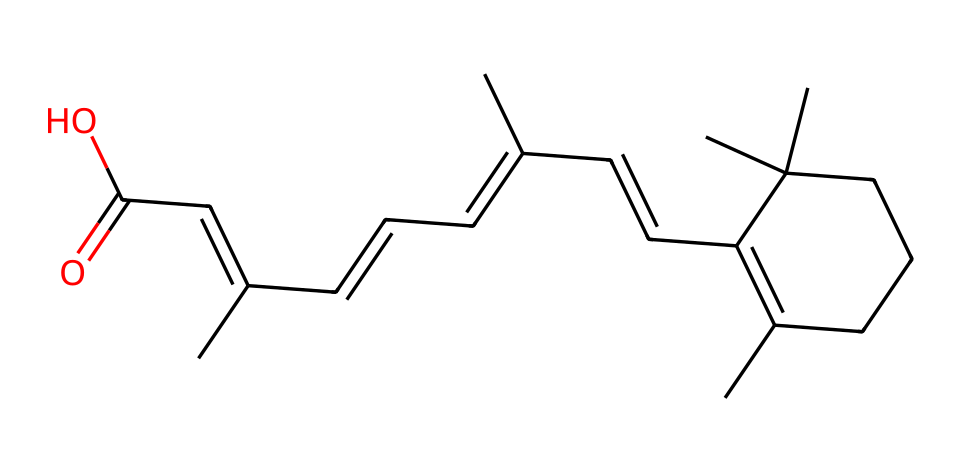What is the molecular formula of retinol? To determine the molecular formula, count the number of carbon (C), hydrogen (H), and oxygen (O) atoms in the given SMILES representation. From the structure, there are 20 carbon atoms, 30 hydrogen atoms, and 1 oxygen atom. Therefore, the molecular formula is C20H30O.
Answer: C20H30O How many rings are present in retinol's structure? Examine the SMILES representation for indications of cyclic structures. In retinol, there is one cyclic structure evident from the 'C1' symbols, indicating a ring closure. Thus, there is 1 ring.
Answer: 1 What functional group is identified in the structure of retinol? Analyzing the functional groups in the compound, the presence of a carbonyl group (C=O) suggests it has an acidic functional group since it connects to a hydroxyl group (OH) in the carboxylic acid at the end of the structure. Therefore, the functional group is a carboxylic acid.
Answer: carboxylic acid What is the total number of double bonds in the retinol molecule? To count the double bonds, look for the '=' symbols in the SMILES. Retinol has 5 instances of double bonds, as identified in its structure. Hence, the total number of double bonds is 5.
Answer: 5 How does retinol's structure contribute to its efficacy in skincare? The presence of multiple double bonds suggests that retinol has a high degree of unsaturation, which is known to enhance its reactivity and ability to penetrate the skin, making it effective in skincare by promoting cell turnover and collagen production.
Answer: enhances penetration 